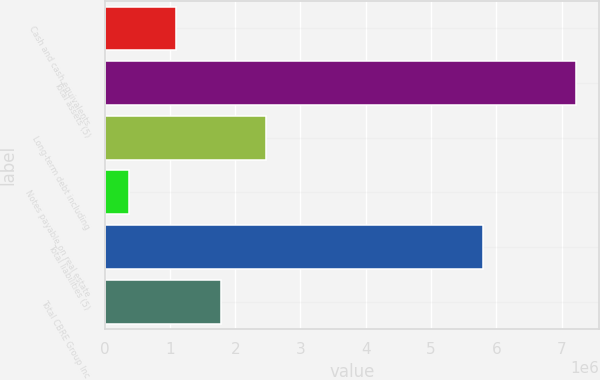Convert chart to OTSL. <chart><loc_0><loc_0><loc_500><loc_500><bar_chart><fcel>Cash and cash equivalents<fcel>Total assets (5)<fcel>Long-term debt including<fcel>Notes payable on real estate<fcel>Total liabilities (5)<fcel>Total CBRE Group Inc<nl><fcel>1.09318e+06<fcel>7.21914e+06<fcel>2.47269e+06<fcel>372912<fcel>5.80198e+06<fcel>1.77781e+06<nl></chart> 